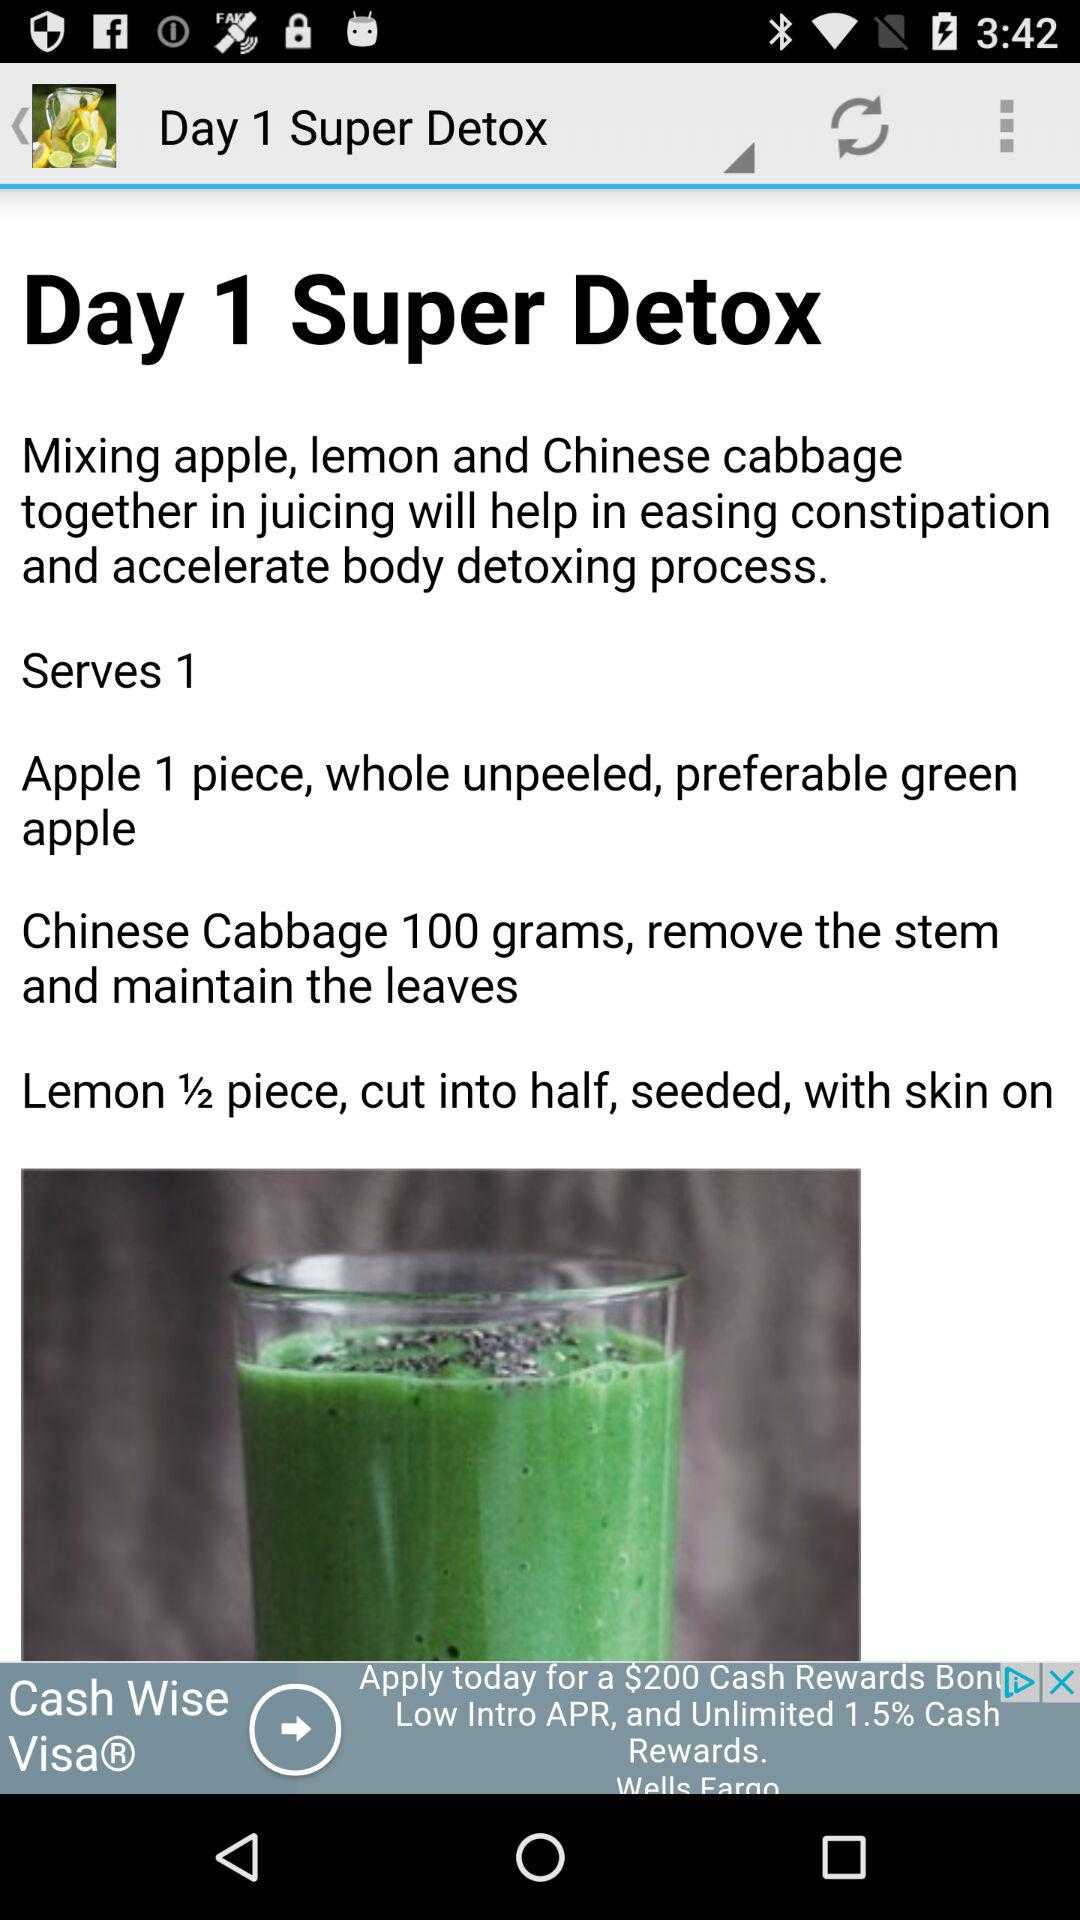What kind of cabbage and how much do you need to make "Super Detox"? The kind of cabbage is Chinese and you need 100 grams of it to make "Super Detox". 